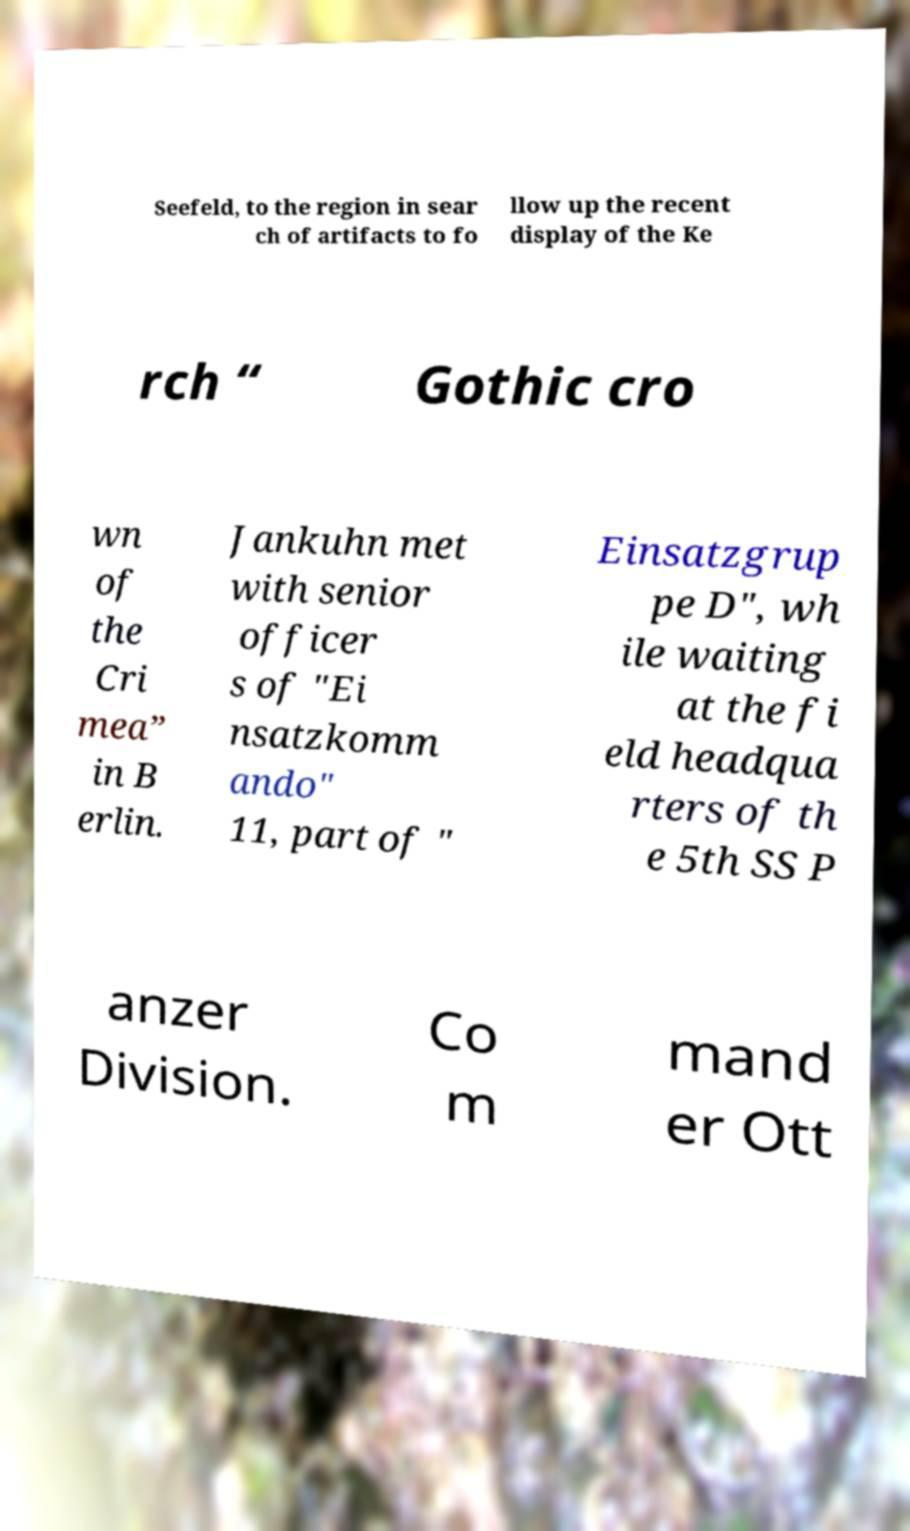Please read and relay the text visible in this image. What does it say? Seefeld, to the region in sear ch of artifacts to fo llow up the recent display of the Ke rch “ Gothic cro wn of the Cri mea” in B erlin. Jankuhn met with senior officer s of "Ei nsatzkomm ando" 11, part of " Einsatzgrup pe D", wh ile waiting at the fi eld headqua rters of th e 5th SS P anzer Division. Co m mand er Ott 